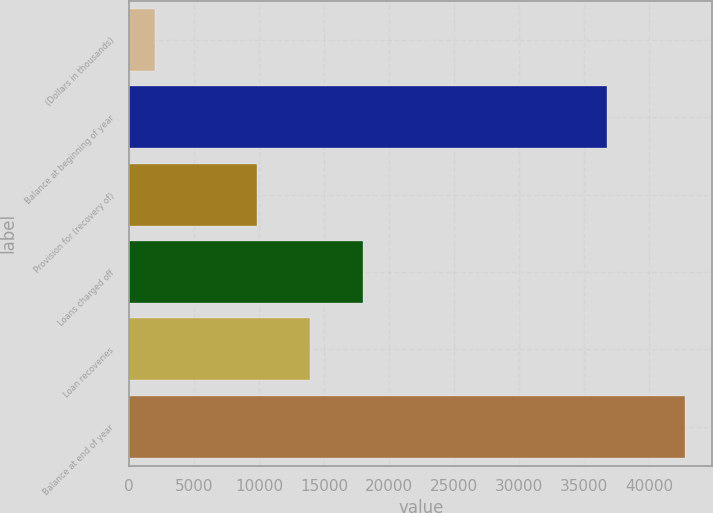Convert chart to OTSL. <chart><loc_0><loc_0><loc_500><loc_500><bar_chart><fcel>(Dollars in thousands)<fcel>Balance at beginning of year<fcel>Provision for (recovery of)<fcel>Loans charged off<fcel>Loan recoveries<fcel>Balance at end of year<nl><fcel>2006<fcel>36785<fcel>9877<fcel>18025.2<fcel>13951.1<fcel>42747<nl></chart> 